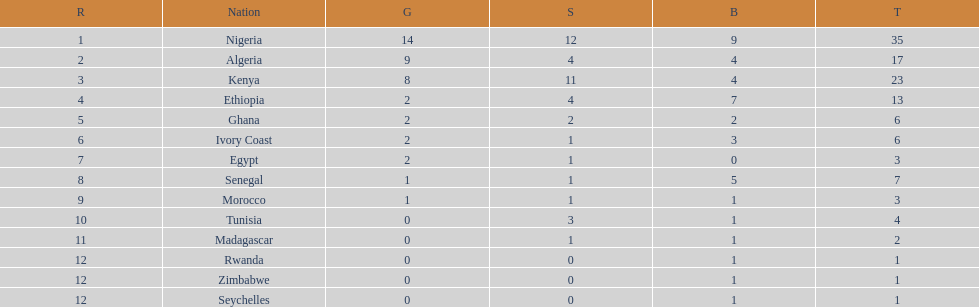Total number of bronze medals nigeria earned? 9. 